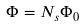<formula> <loc_0><loc_0><loc_500><loc_500>\Phi = N _ { s } \Phi _ { 0 }</formula> 